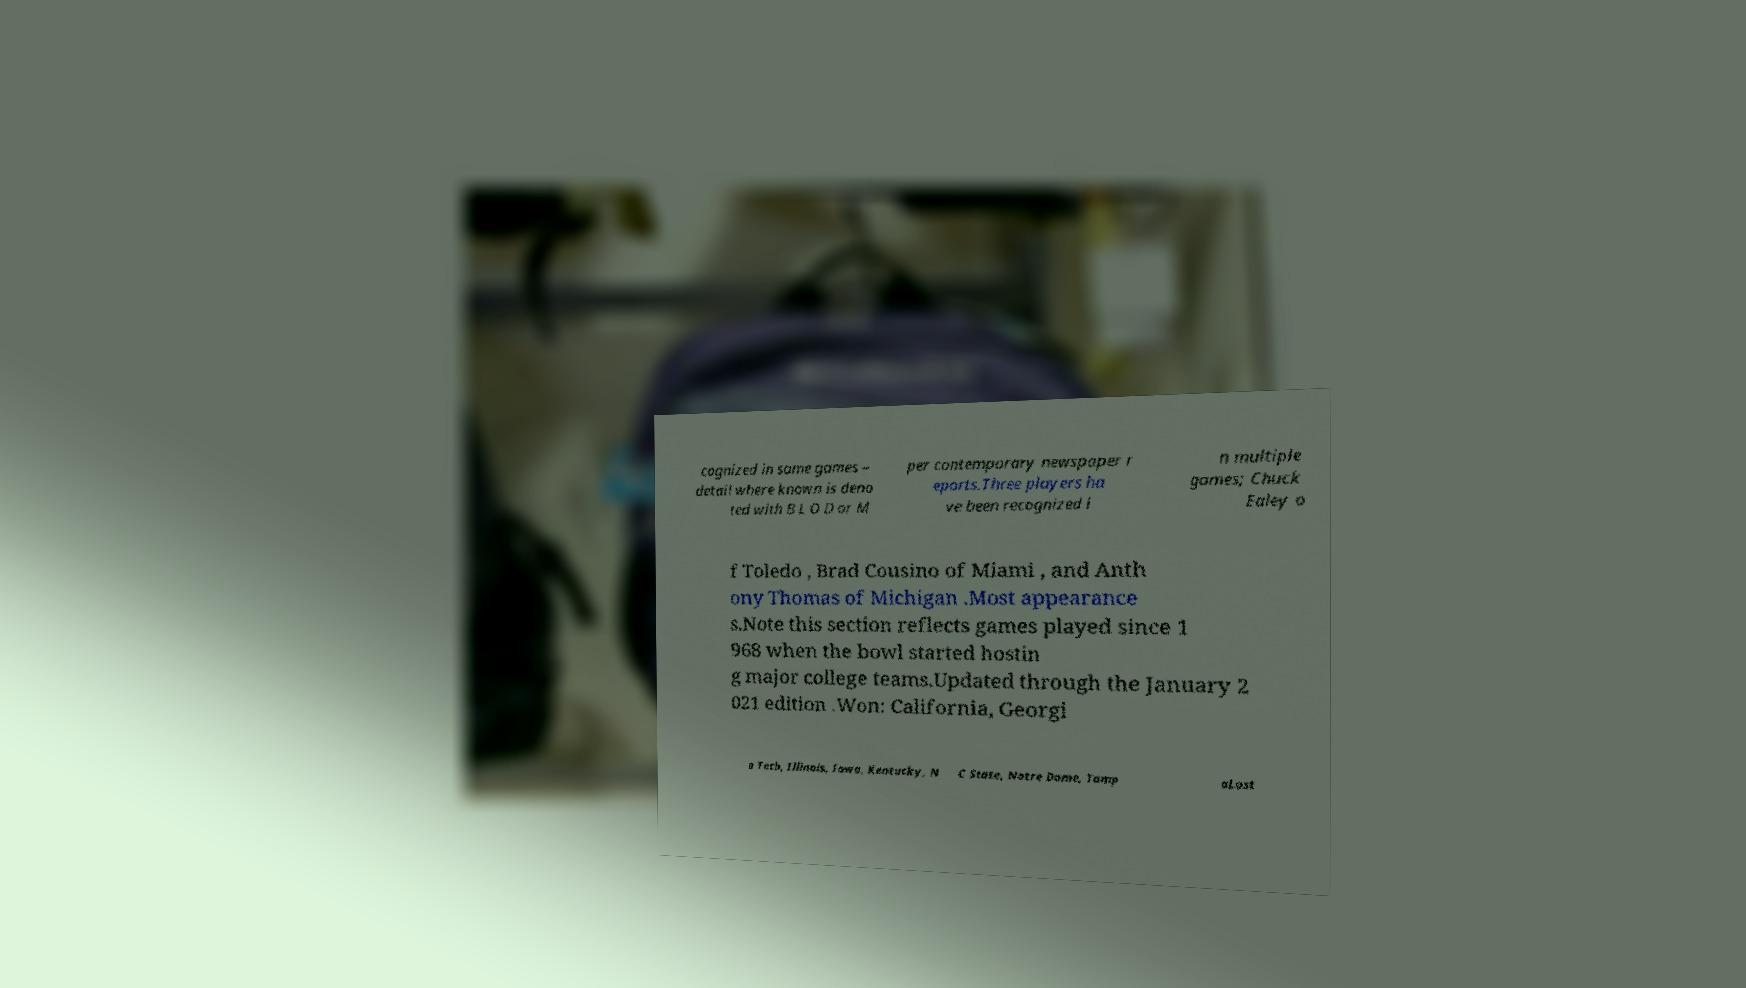Can you accurately transcribe the text from the provided image for me? cognized in some games – detail where known is deno ted with B L O D or M per contemporary newspaper r eports.Three players ha ve been recognized i n multiple games; Chuck Ealey o f Toledo , Brad Cousino of Miami , and Anth ony Thomas of Michigan .Most appearance s.Note this section reflects games played since 1 968 when the bowl started hostin g major college teams.Updated through the January 2 021 edition .Won: California, Georgi a Tech, Illinois, Iowa, Kentucky, N C State, Notre Dame, Tamp aLost 